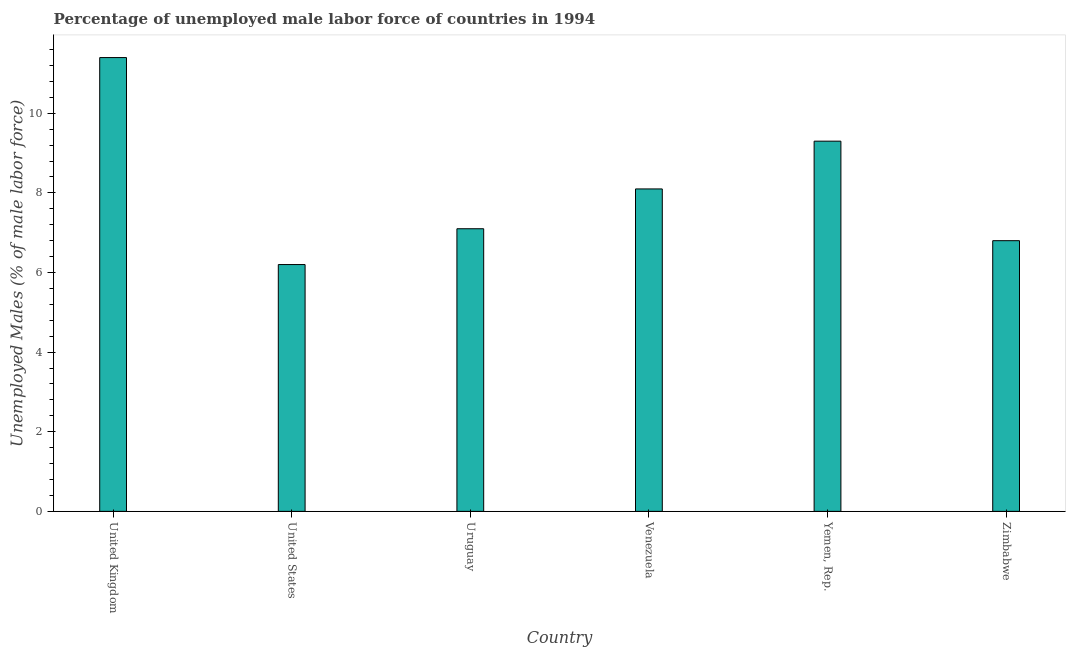Does the graph contain grids?
Make the answer very short. No. What is the title of the graph?
Provide a succinct answer. Percentage of unemployed male labor force of countries in 1994. What is the label or title of the Y-axis?
Your answer should be compact. Unemployed Males (% of male labor force). What is the total unemployed male labour force in Uruguay?
Provide a succinct answer. 7.1. Across all countries, what is the maximum total unemployed male labour force?
Offer a very short reply. 11.4. Across all countries, what is the minimum total unemployed male labour force?
Provide a succinct answer. 6.2. In which country was the total unemployed male labour force minimum?
Offer a very short reply. United States. What is the sum of the total unemployed male labour force?
Ensure brevity in your answer.  48.9. What is the average total unemployed male labour force per country?
Offer a terse response. 8.15. What is the median total unemployed male labour force?
Offer a terse response. 7.6. In how many countries, is the total unemployed male labour force greater than 10.4 %?
Provide a succinct answer. 1. What is the ratio of the total unemployed male labour force in United States to that in Uruguay?
Provide a succinct answer. 0.87. What is the difference between the highest and the second highest total unemployed male labour force?
Keep it short and to the point. 2.1. How many bars are there?
Ensure brevity in your answer.  6. Are all the bars in the graph horizontal?
Ensure brevity in your answer.  No. How many countries are there in the graph?
Make the answer very short. 6. What is the Unemployed Males (% of male labor force) in United Kingdom?
Offer a very short reply. 11.4. What is the Unemployed Males (% of male labor force) in United States?
Ensure brevity in your answer.  6.2. What is the Unemployed Males (% of male labor force) in Uruguay?
Your answer should be compact. 7.1. What is the Unemployed Males (% of male labor force) in Venezuela?
Your answer should be compact. 8.1. What is the Unemployed Males (% of male labor force) of Yemen, Rep.?
Provide a short and direct response. 9.3. What is the Unemployed Males (% of male labor force) in Zimbabwe?
Your answer should be compact. 6.8. What is the difference between the Unemployed Males (% of male labor force) in United Kingdom and United States?
Your answer should be compact. 5.2. What is the difference between the Unemployed Males (% of male labor force) in United Kingdom and Uruguay?
Offer a very short reply. 4.3. What is the difference between the Unemployed Males (% of male labor force) in United Kingdom and Venezuela?
Offer a terse response. 3.3. What is the difference between the Unemployed Males (% of male labor force) in United Kingdom and Zimbabwe?
Provide a succinct answer. 4.6. What is the difference between the Unemployed Males (% of male labor force) in United States and Zimbabwe?
Keep it short and to the point. -0.6. What is the difference between the Unemployed Males (% of male labor force) in Uruguay and Venezuela?
Keep it short and to the point. -1. What is the difference between the Unemployed Males (% of male labor force) in Uruguay and Zimbabwe?
Ensure brevity in your answer.  0.3. What is the difference between the Unemployed Males (% of male labor force) in Venezuela and Yemen, Rep.?
Provide a succinct answer. -1.2. What is the difference between the Unemployed Males (% of male labor force) in Venezuela and Zimbabwe?
Make the answer very short. 1.3. What is the difference between the Unemployed Males (% of male labor force) in Yemen, Rep. and Zimbabwe?
Offer a terse response. 2.5. What is the ratio of the Unemployed Males (% of male labor force) in United Kingdom to that in United States?
Make the answer very short. 1.84. What is the ratio of the Unemployed Males (% of male labor force) in United Kingdom to that in Uruguay?
Your answer should be very brief. 1.61. What is the ratio of the Unemployed Males (% of male labor force) in United Kingdom to that in Venezuela?
Provide a succinct answer. 1.41. What is the ratio of the Unemployed Males (% of male labor force) in United Kingdom to that in Yemen, Rep.?
Your response must be concise. 1.23. What is the ratio of the Unemployed Males (% of male labor force) in United Kingdom to that in Zimbabwe?
Make the answer very short. 1.68. What is the ratio of the Unemployed Males (% of male labor force) in United States to that in Uruguay?
Give a very brief answer. 0.87. What is the ratio of the Unemployed Males (% of male labor force) in United States to that in Venezuela?
Ensure brevity in your answer.  0.77. What is the ratio of the Unemployed Males (% of male labor force) in United States to that in Yemen, Rep.?
Keep it short and to the point. 0.67. What is the ratio of the Unemployed Males (% of male labor force) in United States to that in Zimbabwe?
Give a very brief answer. 0.91. What is the ratio of the Unemployed Males (% of male labor force) in Uruguay to that in Venezuela?
Provide a short and direct response. 0.88. What is the ratio of the Unemployed Males (% of male labor force) in Uruguay to that in Yemen, Rep.?
Ensure brevity in your answer.  0.76. What is the ratio of the Unemployed Males (% of male labor force) in Uruguay to that in Zimbabwe?
Offer a terse response. 1.04. What is the ratio of the Unemployed Males (% of male labor force) in Venezuela to that in Yemen, Rep.?
Your answer should be compact. 0.87. What is the ratio of the Unemployed Males (% of male labor force) in Venezuela to that in Zimbabwe?
Your answer should be very brief. 1.19. What is the ratio of the Unemployed Males (% of male labor force) in Yemen, Rep. to that in Zimbabwe?
Your answer should be very brief. 1.37. 